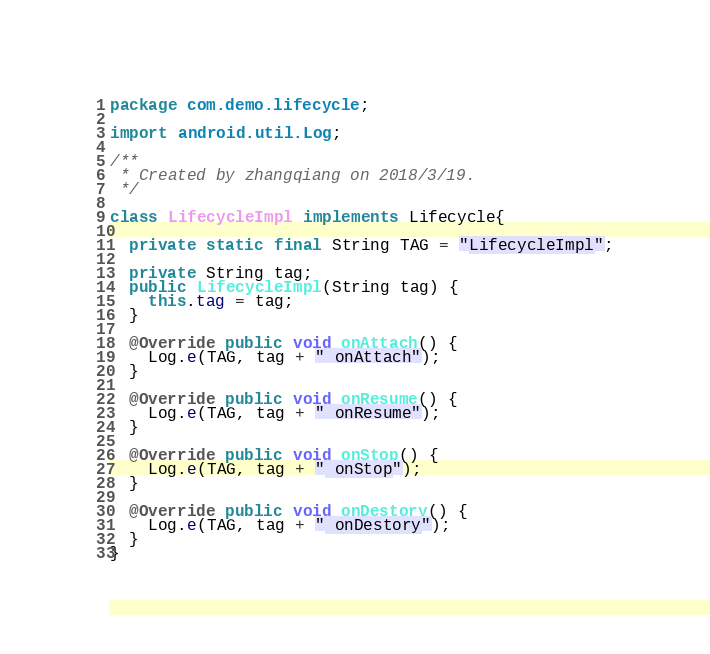<code> <loc_0><loc_0><loc_500><loc_500><_Java_>package com.demo.lifecycle;

import android.util.Log;

/**
 * Created by zhangqiang on 2018/3/19.
 */

class LifecycleImpl implements Lifecycle{

  private static final String TAG = "LifecycleImpl";

  private String tag;
  public LifecycleImpl(String tag) {
    this.tag = tag;
  }

  @Override public void onAttach() {
    Log.e(TAG, tag + " onAttach");
  }

  @Override public void onResume() {
    Log.e(TAG, tag + " onResume");
  }

  @Override public void onStop() {
    Log.e(TAG, tag + " onStop");
  }

  @Override public void onDestory() {
    Log.e(TAG, tag + " onDestory");
  }
}
</code> 